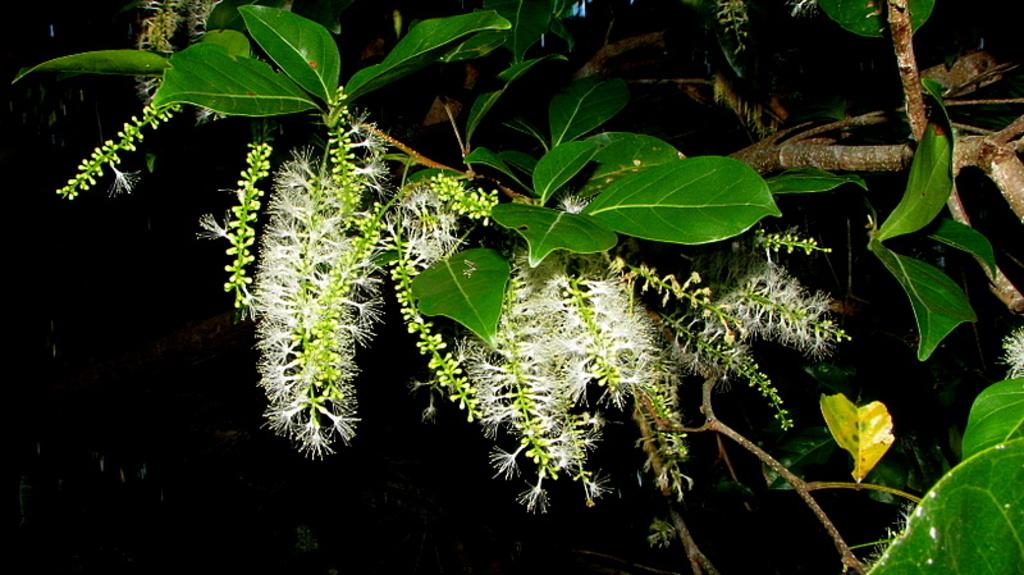What type of vegetation can be seen in the image? There are leaves and flowers in the image. What else is present in the image besides the vegetation? There are branches visible in the image. What is the color of the background in the image? The background of the image is dark. Who is the creator of the flowers in the image? There is no information about the creator of the flowers in the image. Is there any water visible in the image? There is no water present in the image. Are there any vests visible in the image? There is no mention of vests in the image. 